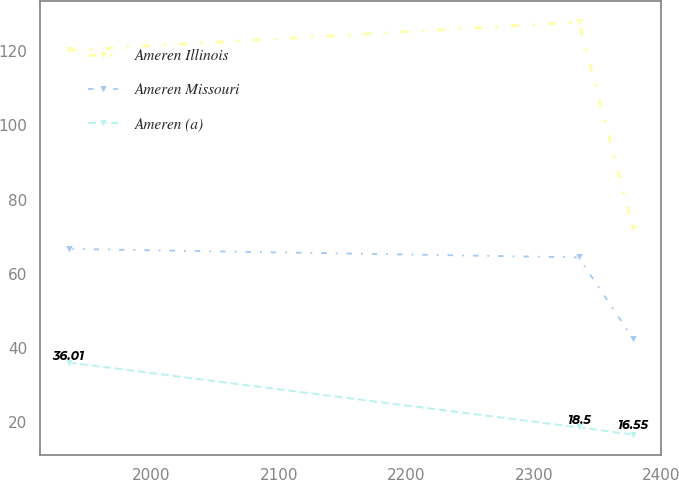Convert chart to OTSL. <chart><loc_0><loc_0><loc_500><loc_500><line_chart><ecel><fcel>Ameren Illinois<fcel>Ameren Missouri<fcel>Ameren (a)<nl><fcel>1934.87<fcel>120.27<fcel>66.68<fcel>36.01<nl><fcel>2335.29<fcel>127.92<fcel>64.4<fcel>18.5<nl><fcel>2377.92<fcel>72.37<fcel>42.41<fcel>16.55<nl></chart> 